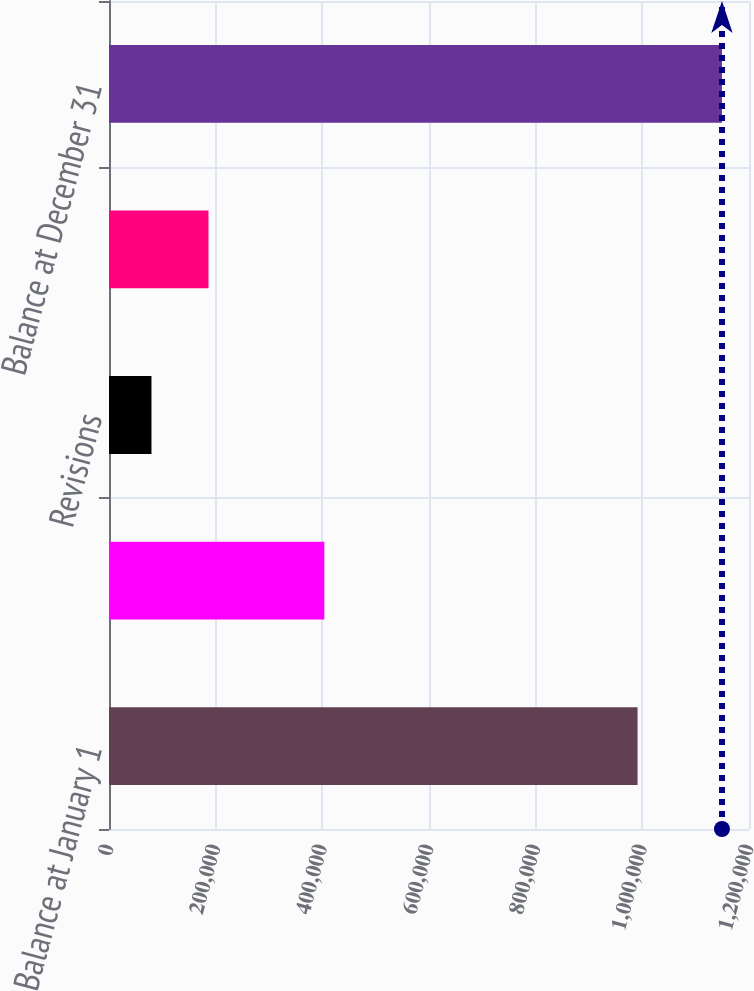<chart> <loc_0><loc_0><loc_500><loc_500><bar_chart><fcel>Balance at January 1<fcel>Extensions and Discoveries<fcel>Revisions<fcel>Conversion to Proved Developed<fcel>Balance at December 31<nl><fcel>991067<fcel>403713<fcel>79630<fcel>186598<fcel>1.14931e+06<nl></chart> 